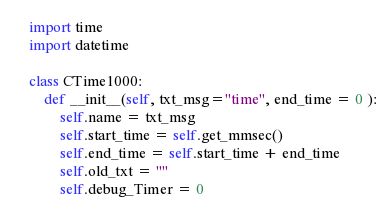Convert code to text. <code><loc_0><loc_0><loc_500><loc_500><_Python_>
import time
import datetime

class CTime1000:
    def __init__(self, txt_msg="time", end_time = 0 ):
        self.name = txt_msg
        self.start_time = self.get_mmsec()
        self.end_time = self.start_time + end_time
        self.old_txt = ""
        self.debug_Timer = 0</code> 